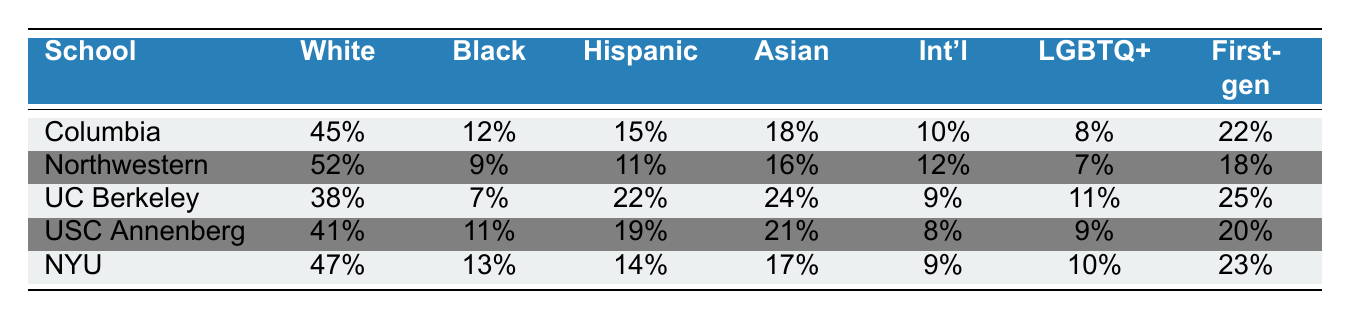What percentage of students at UC Berkeley are Hispanic? From the table, the percentage of Hispanic students at UC Berkeley is clearly stated as 22%.
Answer: 22% Which school has the highest percentage of Black students? By examining the percentages in the Black demographic column, Northwestern has the highest percentage with 9%.
Answer: Northwestern What is the percentage difference in White students between Columbia and USC Annenberg? Columbia has 45% White students while USC Annenberg has 41%. The difference is calculated as 45% - 41% = 4%.
Answer: 4% How many schools have a higher percentage of International students than UC Berkeley? UC Berkeley has 9% International students. Looking at the other schools, Northwestern (12%), and USC Annenberg (8%) have higher percentages. Therefore, 1 school exceeds UC Berkeley's percentage.
Answer: 1 What is the average percentage of LGBTQ+ students across all five journalism schools? To find the average, sum the percentages for LGBTQ+ students: (8 + 7 + 11 + 9 + 10) = 45%. Then divide by 5 (the number of schools) to get an average of 45% / 5 = 9%.
Answer: 9% Which school has the lowest percentage of Hispanic students? The table shows that Northwestern has the lowest percentage of Hispanic students at 11%.
Answer: Northwestern Is it true that USC Annenberg has a higher percentage of First-generation college students than UC Berkeley? USC Annenberg has 20% First-generation college students, while UC Berkeley has 25%. Since 20% < 25%, the statement is false.
Answer: No What is the total percentage of White and Asian students combined at NYU? At NYU, White students comprise 47% and Asian students 17%. Adding these together gives: 47% + 17% = 64%.
Answer: 64% How does the percentage of First-generation college students at Columbia compare to that at NYU? Columbia has 22% First-generation college students while NYU has 23%. NYU's percentage is higher by 1%.
Answer: 1% higher at NYU Which school has the highest overall diversity in terms of minority representation? To determine this, consider the lower percentages for minority groups—UC Berkeley has diverse representation with percentages like 7% Black, 22% Hispanic, and 24% Asian. This variety gives it the highest minority diversity.
Answer: UC Berkeley 